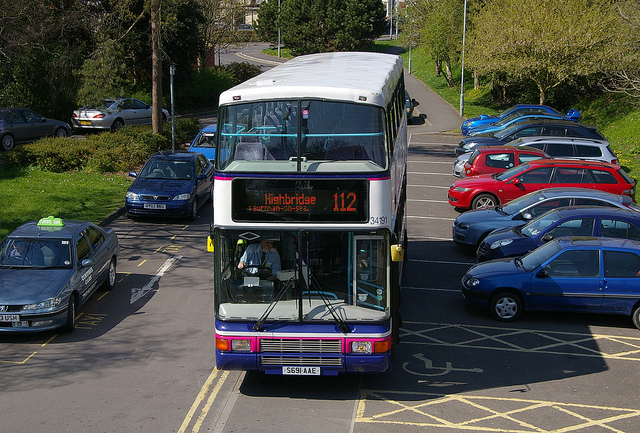Read and extract the text from this image. Highbridge 112 34191 S591-AAE TAXI 